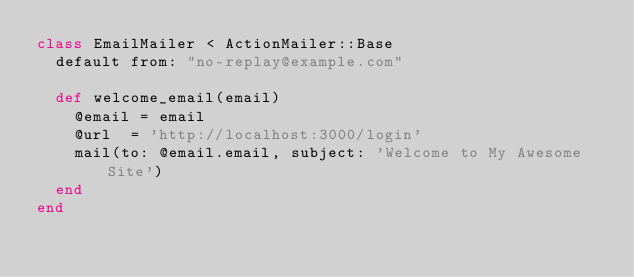<code> <loc_0><loc_0><loc_500><loc_500><_Ruby_>class EmailMailer < ActionMailer::Base
  default from: "no-replay@example.com"

  def welcome_email(email)
    @email = email
    @url  = 'http://localhost:3000/login'
    mail(to: @email.email, subject: 'Welcome to My Awesome Site')
  end
end
</code> 